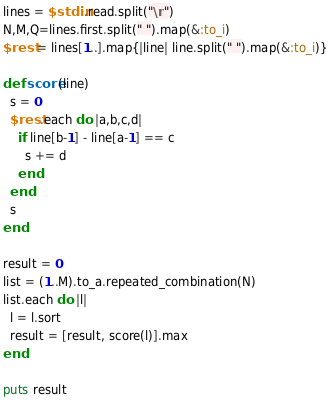Convert code to text. <code><loc_0><loc_0><loc_500><loc_500><_Ruby_>lines = $stdin.read.split("\n")
N,M,Q=lines.first.split(" ").map(&:to_i)
$rest = lines[1..].map{|line| line.split(" ").map(&:to_i)}

def score(line)
  s = 0
  $rest.each do |a,b,c,d|
    if line[b-1] - line[a-1] == c
      s += d
    end
  end
  s
end

result = 0
list = (1..M).to_a.repeated_combination(N)
list.each do |l|
  l = l.sort
  result = [result, score(l)].max
end

puts result</code> 